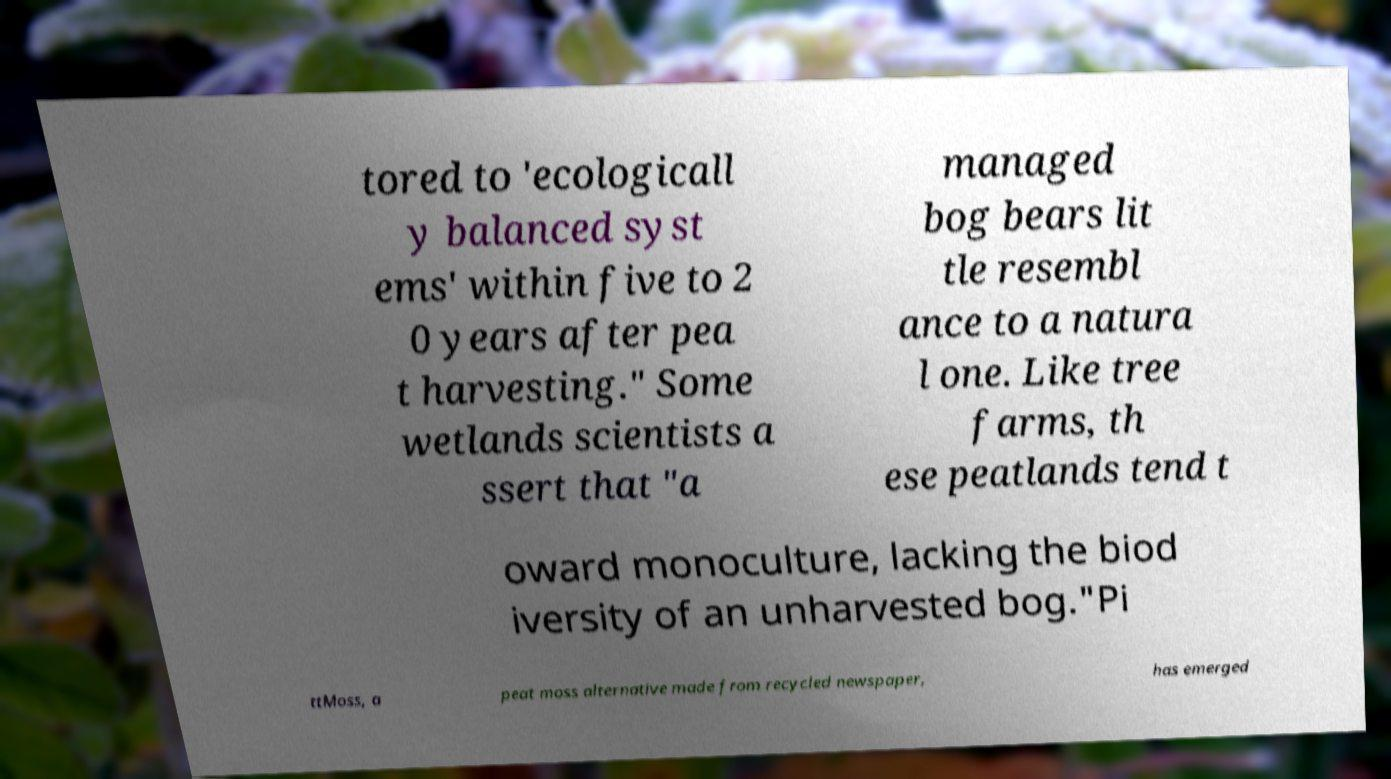There's text embedded in this image that I need extracted. Can you transcribe it verbatim? tored to 'ecologicall y balanced syst ems' within five to 2 0 years after pea t harvesting." Some wetlands scientists a ssert that "a managed bog bears lit tle resembl ance to a natura l one. Like tree farms, th ese peatlands tend t oward monoculture, lacking the biod iversity of an unharvested bog."Pi ttMoss, a peat moss alternative made from recycled newspaper, has emerged 